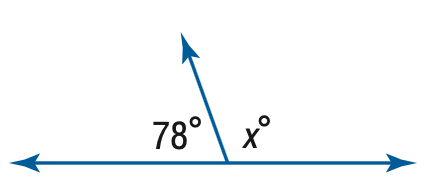Answer the mathemtical geometry problem and directly provide the correct option letter.
Question: Find x.
Choices: A: 92 B: 102 C: 112 D: 122 B 